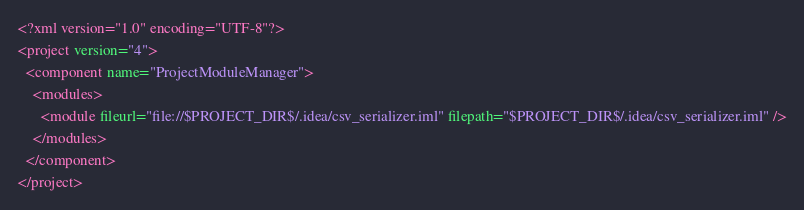Convert code to text. <code><loc_0><loc_0><loc_500><loc_500><_XML_><?xml version="1.0" encoding="UTF-8"?>
<project version="4">
  <component name="ProjectModuleManager">
    <modules>
      <module fileurl="file://$PROJECT_DIR$/.idea/csv_serializer.iml" filepath="$PROJECT_DIR$/.idea/csv_serializer.iml" />
    </modules>
  </component>
</project></code> 